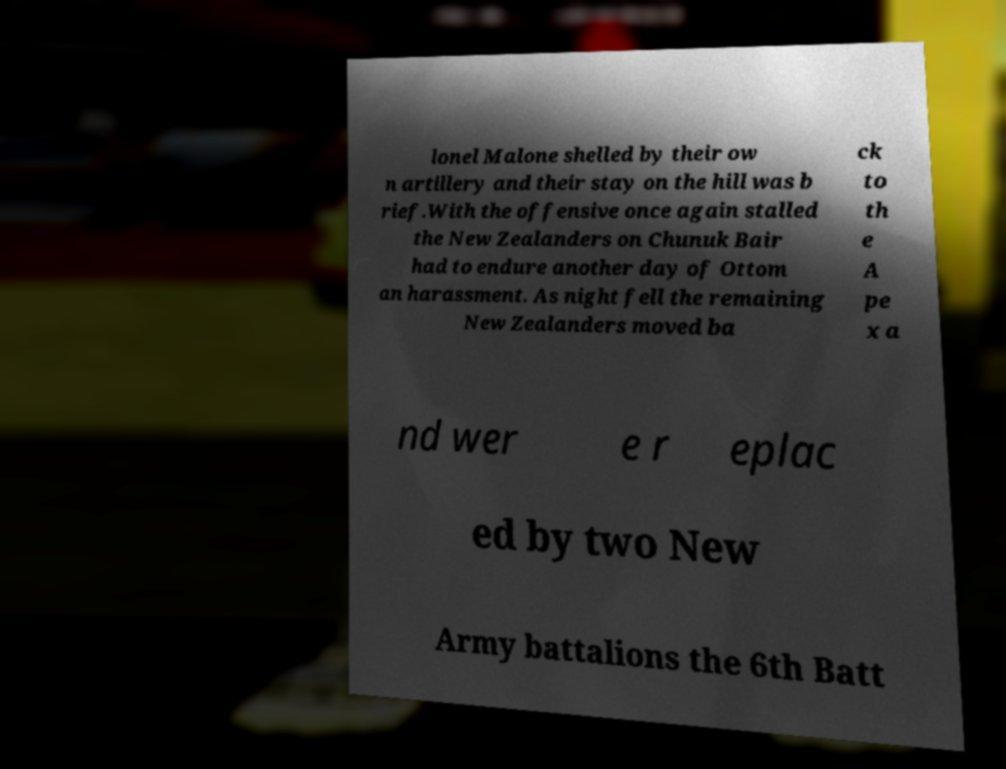Could you assist in decoding the text presented in this image and type it out clearly? lonel Malone shelled by their ow n artillery and their stay on the hill was b rief.With the offensive once again stalled the New Zealanders on Chunuk Bair had to endure another day of Ottom an harassment. As night fell the remaining New Zealanders moved ba ck to th e A pe x a nd wer e r eplac ed by two New Army battalions the 6th Batt 